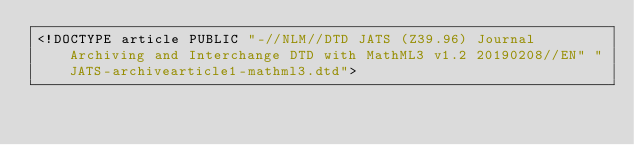<code> <loc_0><loc_0><loc_500><loc_500><_XML_><!DOCTYPE article PUBLIC "-//NLM//DTD JATS (Z39.96) Journal Archiving and Interchange DTD with MathML3 v1.2 20190208//EN" "JATS-archivearticle1-mathml3.dtd"> </code> 